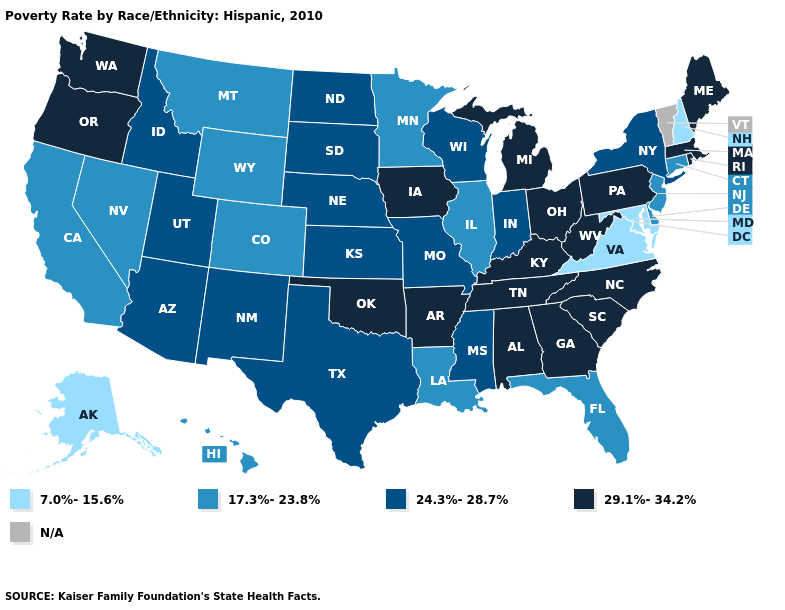What is the value of Minnesota?
Quick response, please. 17.3%-23.8%. Name the states that have a value in the range 24.3%-28.7%?
Write a very short answer. Arizona, Idaho, Indiana, Kansas, Mississippi, Missouri, Nebraska, New Mexico, New York, North Dakota, South Dakota, Texas, Utah, Wisconsin. Among the states that border Connecticut , does New York have the lowest value?
Concise answer only. Yes. What is the lowest value in the Northeast?
Write a very short answer. 7.0%-15.6%. Name the states that have a value in the range N/A?
Short answer required. Vermont. What is the lowest value in states that border Vermont?
Give a very brief answer. 7.0%-15.6%. Among the states that border Utah , which have the highest value?
Keep it brief. Arizona, Idaho, New Mexico. Does the first symbol in the legend represent the smallest category?
Write a very short answer. Yes. What is the lowest value in the USA?
Answer briefly. 7.0%-15.6%. What is the value of Mississippi?
Keep it brief. 24.3%-28.7%. Among the states that border Missouri , which have the lowest value?
Write a very short answer. Illinois. Among the states that border Virginia , which have the lowest value?
Quick response, please. Maryland. Is the legend a continuous bar?
Quick response, please. No. Does South Dakota have the lowest value in the USA?
Keep it brief. No. 